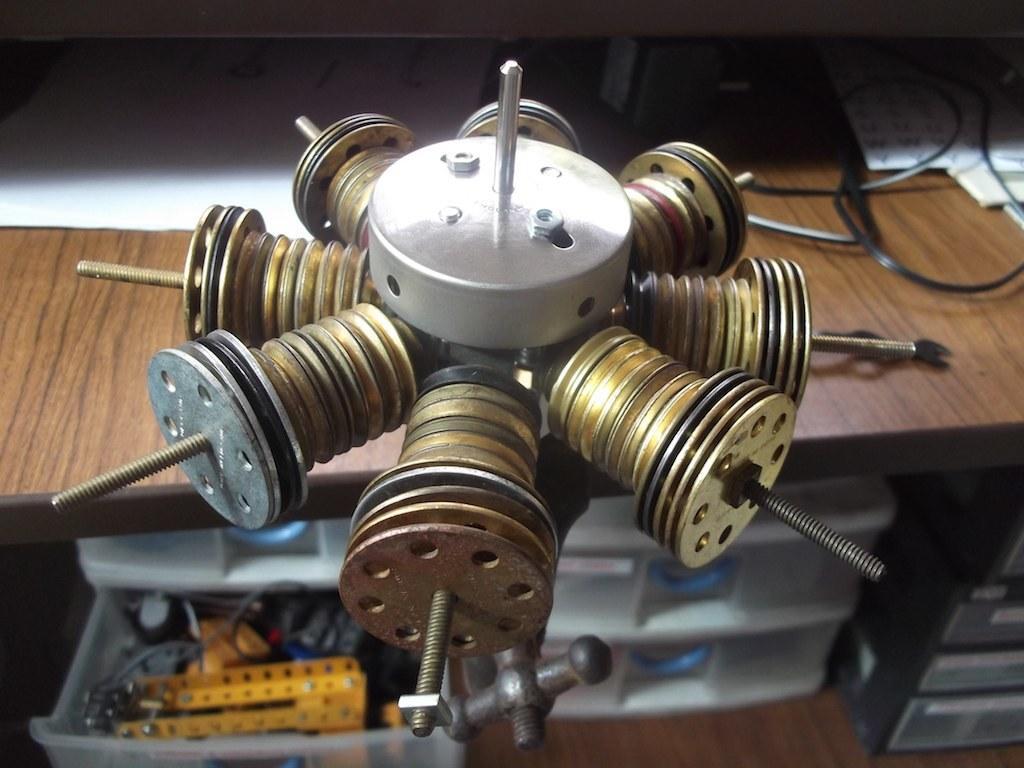Can you describe this image briefly? Here we can see a device, papers, cables, and boxes. This is a table. 